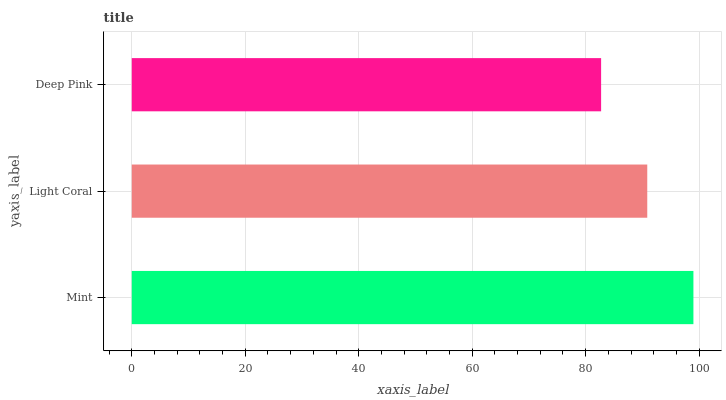Is Deep Pink the minimum?
Answer yes or no. Yes. Is Mint the maximum?
Answer yes or no. Yes. Is Light Coral the minimum?
Answer yes or no. No. Is Light Coral the maximum?
Answer yes or no. No. Is Mint greater than Light Coral?
Answer yes or no. Yes. Is Light Coral less than Mint?
Answer yes or no. Yes. Is Light Coral greater than Mint?
Answer yes or no. No. Is Mint less than Light Coral?
Answer yes or no. No. Is Light Coral the high median?
Answer yes or no. Yes. Is Light Coral the low median?
Answer yes or no. Yes. Is Mint the high median?
Answer yes or no. No. Is Deep Pink the low median?
Answer yes or no. No. 